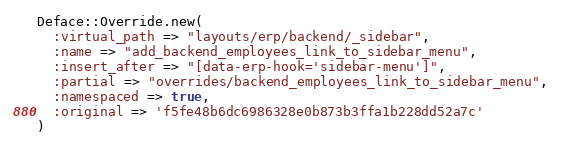<code> <loc_0><loc_0><loc_500><loc_500><_Ruby_>Deface::Override.new(
  :virtual_path => "layouts/erp/backend/_sidebar",
  :name => "add_backend_employees_link_to_sidebar_menu",
  :insert_after => "[data-erp-hook='sidebar-menu']",
  :partial => "overrides/backend_employees_link_to_sidebar_menu",
  :namespaced => true,
  :original => 'f5fe48b6dc6986328e0b873b3ffa1b228dd52a7c'
)</code> 